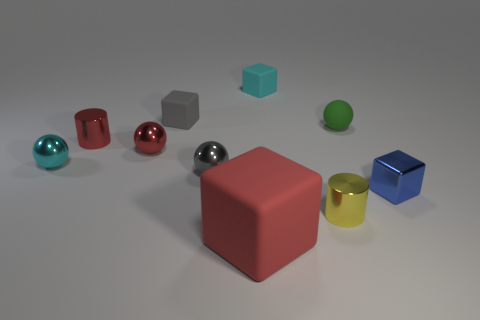Subtract all cyan balls. How many balls are left? 3 Subtract 3 balls. How many balls are left? 1 Subtract all gray balls. How many balls are left? 3 Subtract all green cubes. How many gray cylinders are left? 0 Subtract all green objects. Subtract all green spheres. How many objects are left? 8 Add 7 yellow metal objects. How many yellow metal objects are left? 8 Add 7 cyan spheres. How many cyan spheres exist? 8 Subtract 0 purple cylinders. How many objects are left? 10 Subtract all cylinders. How many objects are left? 8 Subtract all green spheres. Subtract all blue cylinders. How many spheres are left? 3 